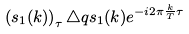Convert formula to latex. <formula><loc_0><loc_0><loc_500><loc_500>\left ( s _ { 1 } ( k ) \right ) _ { \tau } \triangle q s _ { 1 } ( k ) e ^ { - i 2 \pi \frac { k } { T } \tau }</formula> 